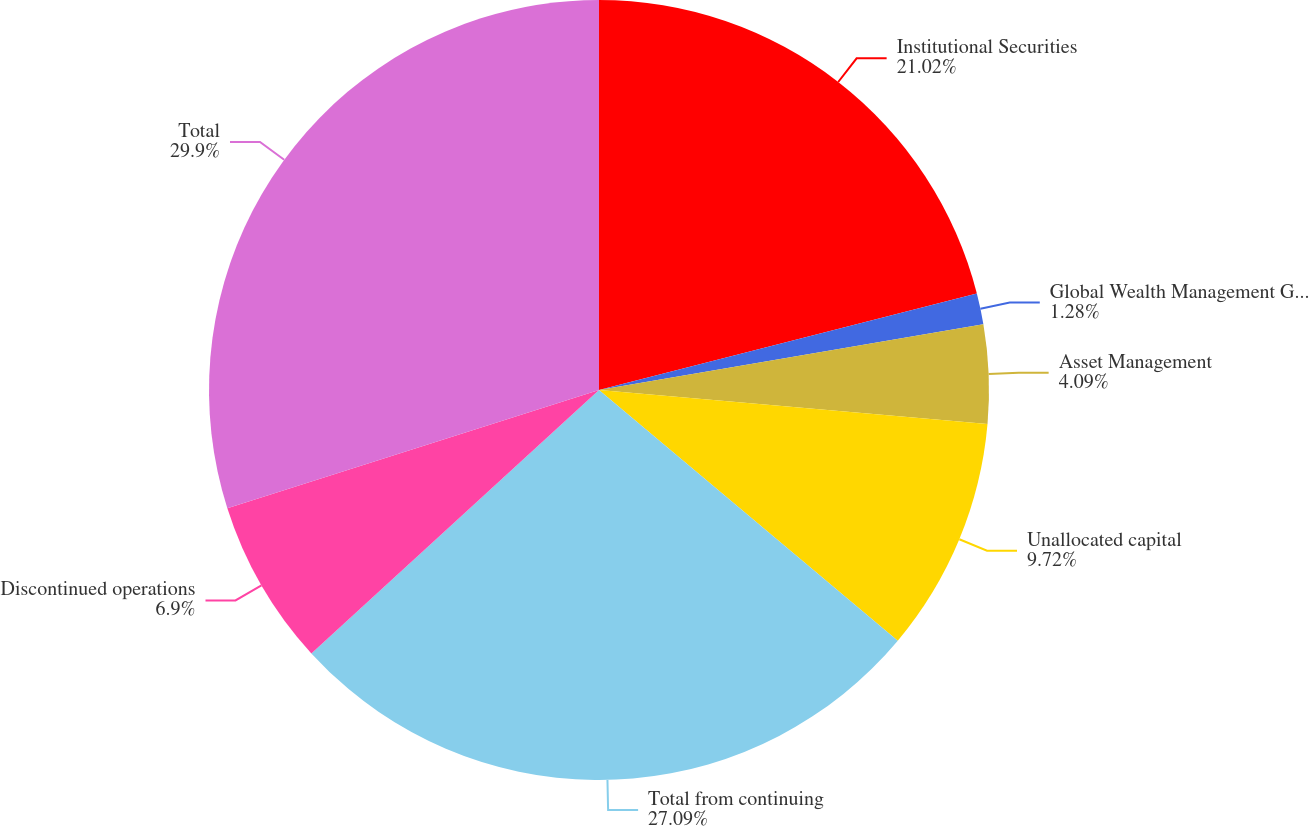Convert chart to OTSL. <chart><loc_0><loc_0><loc_500><loc_500><pie_chart><fcel>Institutional Securities<fcel>Global Wealth Management Group<fcel>Asset Management<fcel>Unallocated capital<fcel>Total from continuing<fcel>Discontinued operations<fcel>Total<nl><fcel>21.02%<fcel>1.28%<fcel>4.09%<fcel>9.72%<fcel>27.09%<fcel>6.9%<fcel>29.9%<nl></chart> 